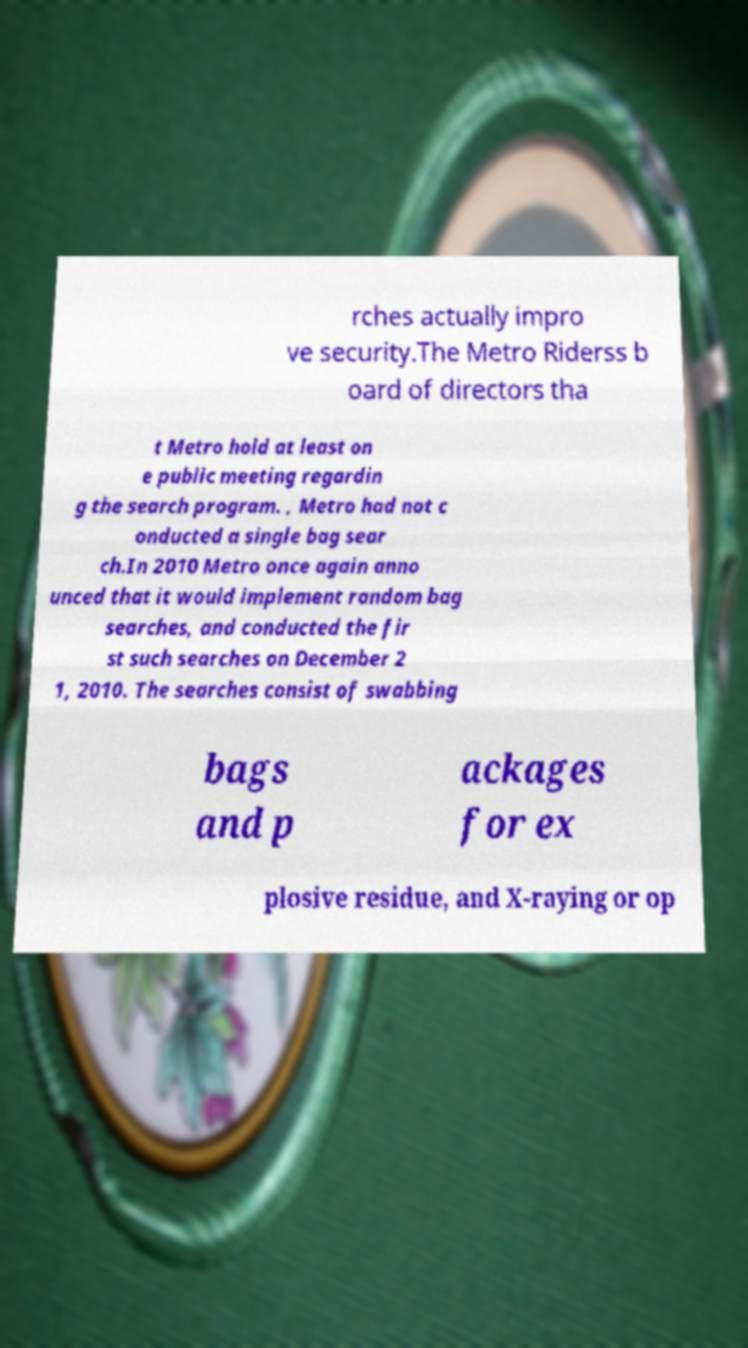Can you read and provide the text displayed in the image?This photo seems to have some interesting text. Can you extract and type it out for me? rches actually impro ve security.The Metro Riderss b oard of directors tha t Metro hold at least on e public meeting regardin g the search program. , Metro had not c onducted a single bag sear ch.In 2010 Metro once again anno unced that it would implement random bag searches, and conducted the fir st such searches on December 2 1, 2010. The searches consist of swabbing bags and p ackages for ex plosive residue, and X-raying or op 